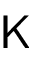Convert formula to latex. <formula><loc_0><loc_0><loc_500><loc_500>K</formula> 